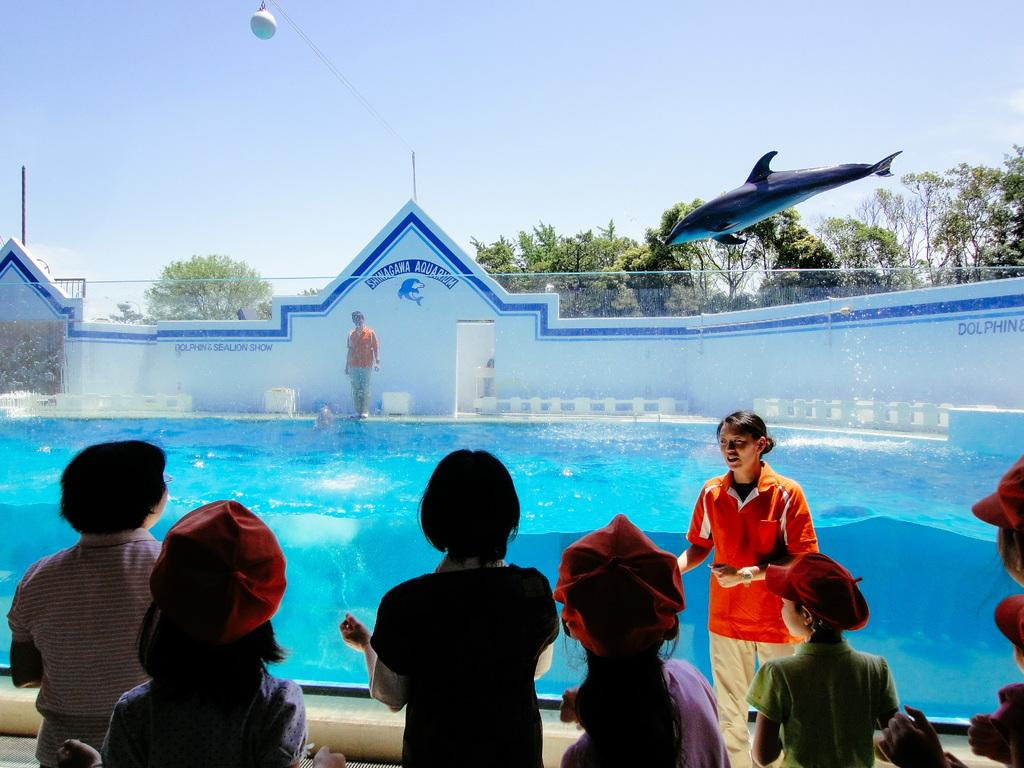What type of vegetation can be seen in the image? There are trees in the image. What animal is performing an action in the water? A dolphin is jumping in the water. Can you describe the people in the image? There are people standing in the image, and some of them are wearing caps. What is visible in the sky in the image? There are clouds in the sky. What type of fan can be seen in the image? There is no fan present in the image. What sound does the thunder make in the image? There is no thunder present in the image; only clouds are visible in the sky. 